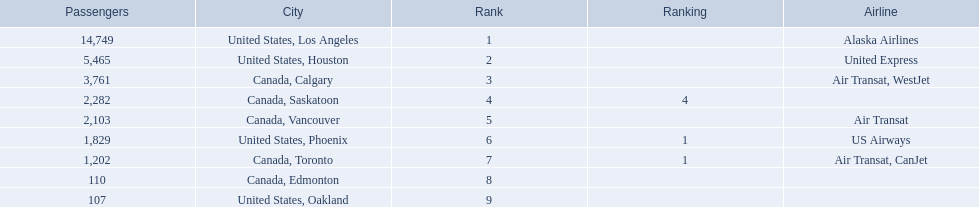What were all the passenger totals? 14,749, 5,465, 3,761, 2,282, 2,103, 1,829, 1,202, 110, 107. Which of these were to los angeles? 14,749. What other destination combined with this is closest to 19,000? Canada, Calgary. 